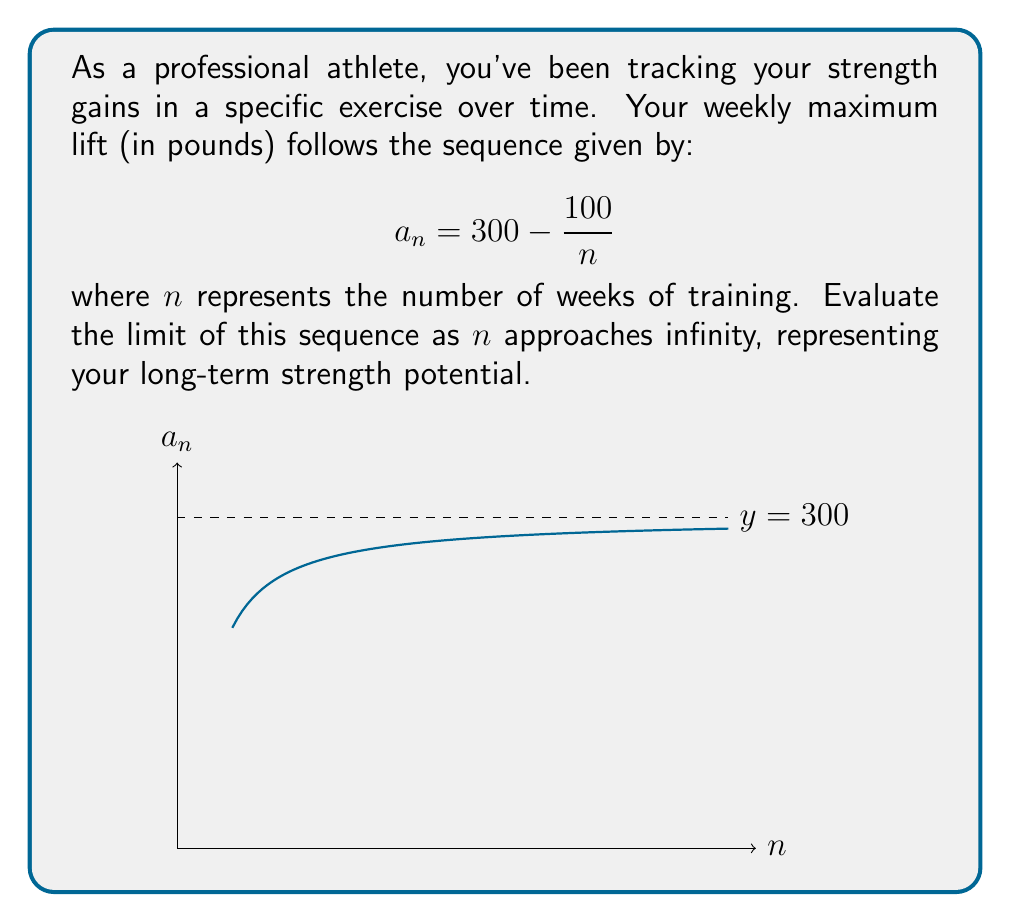Teach me how to tackle this problem. Let's approach this step-by-step:

1) We're given the sequence $a_n = 300 - \frac{100}{n}$, and we need to find $\lim_{n \to \infty} a_n$.

2) As $n$ approaches infinity, let's consider what happens to each part of the expression:

   - The constant term 300 remains unchanged.
   - In the fraction $\frac{100}{n}$, as $n$ gets larger, this term gets smaller.

3) We can evaluate this limit formally:

   $$\lim_{n \to \infty} a_n = \lim_{n \to \infty} (300 - \frac{100}{n})$$

4) Using the limit laws, we can separate this into two limits:

   $$= \lim_{n \to \infty} 300 - \lim_{n \to \infty} \frac{100}{n}$$

5) The limit of a constant is the constant itself:

   $$= 300 - \lim_{n \to \infty} \frac{100}{n}$$

6) Now, as $n$ approaches infinity, $\frac{100}{n}$ approaches 0:

   $$= 300 - 0 = 300$$

Therefore, the limit of the sequence as $n$ approaches infinity is 300.

This represents the theoretical maximum strength you could achieve with this exercise over a very long period of consistent training.
Answer: $300$ 